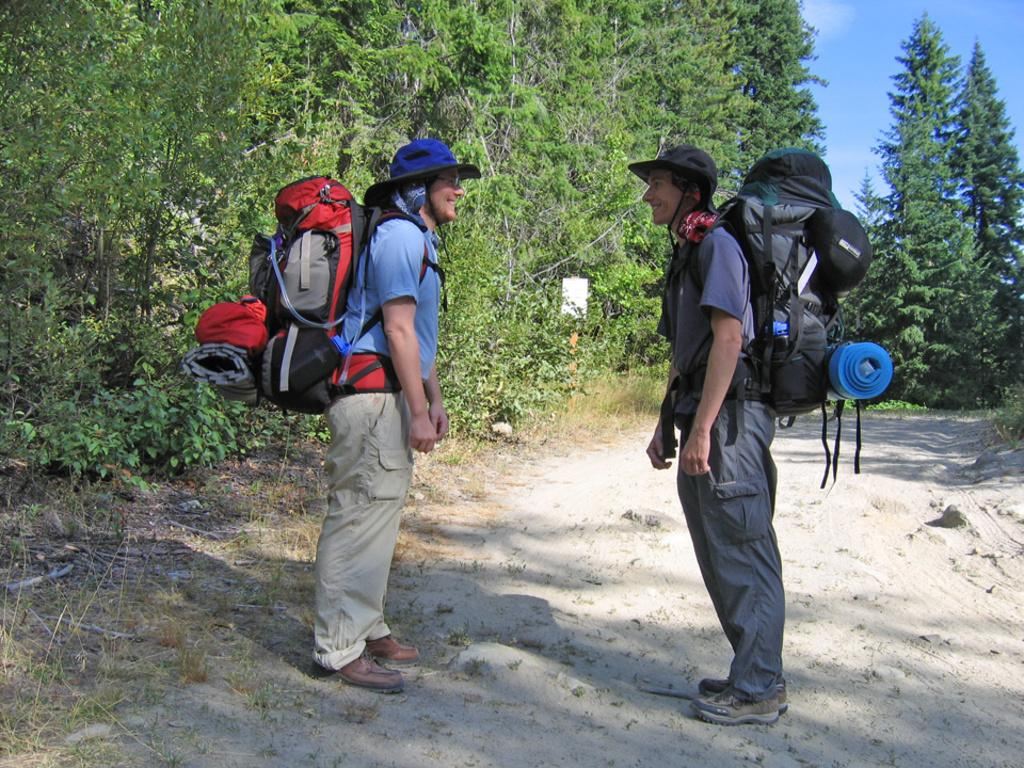How many people are in the image? There are two people in the image. What are the people wearing on their heads? Both people are wearing hats. What are the people carrying in the image? Both people are carrying travel bags. What is the interaction between the two people? The two people are staring at each other and laughing. What type of natural environment is visible in the image? There are trees visible in the image. Can you tell me how many grapes are in the image? There are no grapes present in the image. Are there any horses visible in the image? There are no horses visible in the image. 